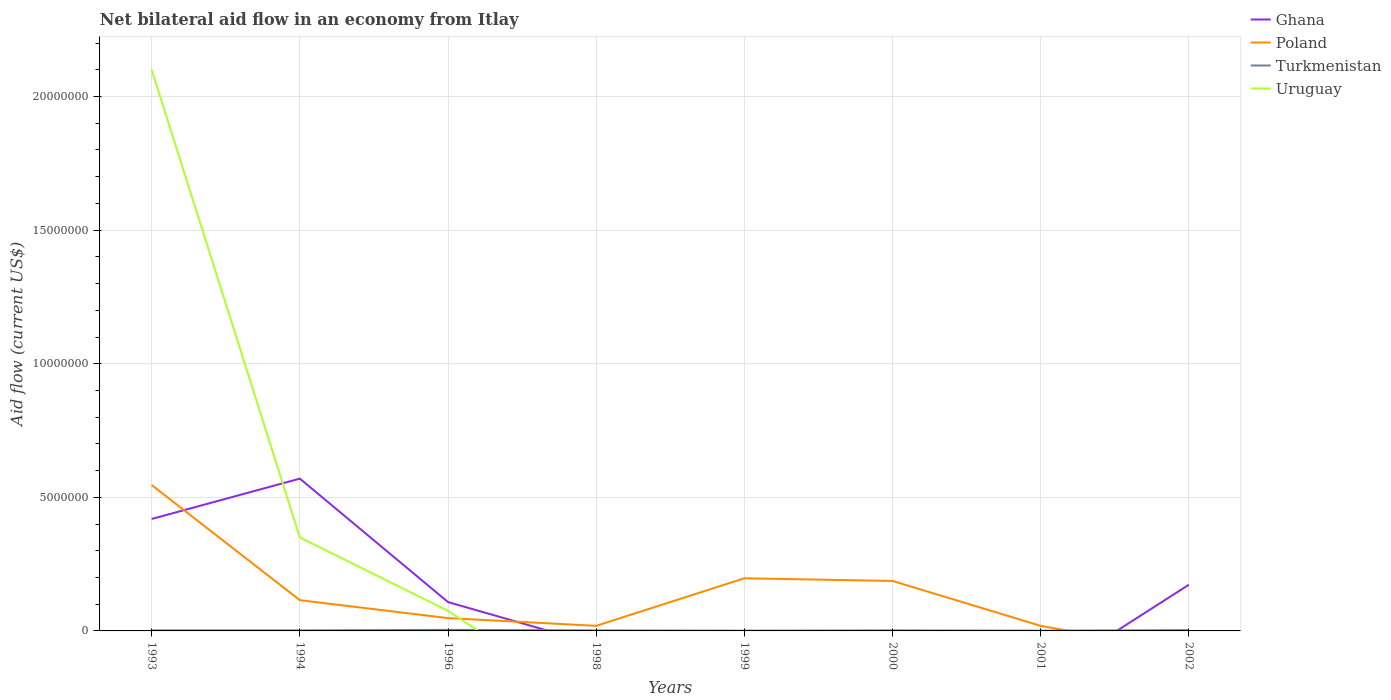Is the number of lines equal to the number of legend labels?
Make the answer very short. No. Is the net bilateral aid flow in Turkmenistan strictly greater than the net bilateral aid flow in Poland over the years?
Your answer should be compact. No. How many lines are there?
Provide a succinct answer. 4. Are the values on the major ticks of Y-axis written in scientific E-notation?
Keep it short and to the point. No. Does the graph contain any zero values?
Your answer should be very brief. Yes. How many legend labels are there?
Your answer should be compact. 4. How are the legend labels stacked?
Ensure brevity in your answer.  Vertical. What is the title of the graph?
Provide a succinct answer. Net bilateral aid flow in an economy from Itlay. What is the Aid flow (current US$) of Ghana in 1993?
Keep it short and to the point. 4.19e+06. What is the Aid flow (current US$) in Poland in 1993?
Provide a succinct answer. 5.46e+06. What is the Aid flow (current US$) in Turkmenistan in 1993?
Your response must be concise. 2.00e+04. What is the Aid flow (current US$) in Uruguay in 1993?
Ensure brevity in your answer.  2.10e+07. What is the Aid flow (current US$) of Ghana in 1994?
Your answer should be very brief. 5.70e+06. What is the Aid flow (current US$) of Poland in 1994?
Your answer should be compact. 1.15e+06. What is the Aid flow (current US$) of Uruguay in 1994?
Offer a very short reply. 3.50e+06. What is the Aid flow (current US$) in Ghana in 1996?
Offer a terse response. 1.08e+06. What is the Aid flow (current US$) of Poland in 1996?
Offer a terse response. 4.80e+05. What is the Aid flow (current US$) of Turkmenistan in 1996?
Your answer should be very brief. 4.00e+04. What is the Aid flow (current US$) in Uruguay in 1996?
Make the answer very short. 7.50e+05. What is the Aid flow (current US$) in Ghana in 1998?
Give a very brief answer. 0. What is the Aid flow (current US$) of Turkmenistan in 1998?
Your answer should be compact. 2.00e+04. What is the Aid flow (current US$) in Uruguay in 1998?
Offer a terse response. 0. What is the Aid flow (current US$) in Poland in 1999?
Your response must be concise. 1.97e+06. What is the Aid flow (current US$) in Ghana in 2000?
Offer a very short reply. 0. What is the Aid flow (current US$) in Poland in 2000?
Ensure brevity in your answer.  1.87e+06. What is the Aid flow (current US$) in Ghana in 2001?
Make the answer very short. 0. What is the Aid flow (current US$) of Turkmenistan in 2001?
Make the answer very short. 10000. What is the Aid flow (current US$) in Uruguay in 2001?
Your answer should be compact. 0. What is the Aid flow (current US$) in Ghana in 2002?
Provide a succinct answer. 1.73e+06. What is the Aid flow (current US$) of Poland in 2002?
Your response must be concise. 0. What is the Aid flow (current US$) of Turkmenistan in 2002?
Provide a short and direct response. 3.00e+04. What is the Aid flow (current US$) in Uruguay in 2002?
Your answer should be compact. 0. Across all years, what is the maximum Aid flow (current US$) of Ghana?
Provide a succinct answer. 5.70e+06. Across all years, what is the maximum Aid flow (current US$) in Poland?
Offer a very short reply. 5.46e+06. Across all years, what is the maximum Aid flow (current US$) in Turkmenistan?
Offer a terse response. 4.00e+04. Across all years, what is the maximum Aid flow (current US$) in Uruguay?
Offer a terse response. 2.10e+07. Across all years, what is the minimum Aid flow (current US$) of Ghana?
Your response must be concise. 0. Across all years, what is the minimum Aid flow (current US$) in Turkmenistan?
Provide a short and direct response. 10000. Across all years, what is the minimum Aid flow (current US$) in Uruguay?
Keep it short and to the point. 0. What is the total Aid flow (current US$) in Ghana in the graph?
Your answer should be very brief. 1.27e+07. What is the total Aid flow (current US$) of Poland in the graph?
Make the answer very short. 1.13e+07. What is the total Aid flow (current US$) of Uruguay in the graph?
Offer a very short reply. 2.52e+07. What is the difference between the Aid flow (current US$) in Ghana in 1993 and that in 1994?
Offer a very short reply. -1.51e+06. What is the difference between the Aid flow (current US$) in Poland in 1993 and that in 1994?
Your answer should be compact. 4.31e+06. What is the difference between the Aid flow (current US$) in Turkmenistan in 1993 and that in 1994?
Give a very brief answer. 0. What is the difference between the Aid flow (current US$) of Uruguay in 1993 and that in 1994?
Give a very brief answer. 1.75e+07. What is the difference between the Aid flow (current US$) in Ghana in 1993 and that in 1996?
Provide a short and direct response. 3.11e+06. What is the difference between the Aid flow (current US$) in Poland in 1993 and that in 1996?
Make the answer very short. 4.98e+06. What is the difference between the Aid flow (current US$) in Turkmenistan in 1993 and that in 1996?
Keep it short and to the point. -2.00e+04. What is the difference between the Aid flow (current US$) of Uruguay in 1993 and that in 1996?
Make the answer very short. 2.02e+07. What is the difference between the Aid flow (current US$) of Poland in 1993 and that in 1998?
Ensure brevity in your answer.  5.27e+06. What is the difference between the Aid flow (current US$) of Turkmenistan in 1993 and that in 1998?
Provide a short and direct response. 0. What is the difference between the Aid flow (current US$) in Poland in 1993 and that in 1999?
Ensure brevity in your answer.  3.49e+06. What is the difference between the Aid flow (current US$) of Poland in 1993 and that in 2000?
Your response must be concise. 3.59e+06. What is the difference between the Aid flow (current US$) in Turkmenistan in 1993 and that in 2000?
Your answer should be compact. 0. What is the difference between the Aid flow (current US$) in Poland in 1993 and that in 2001?
Your answer should be very brief. 5.27e+06. What is the difference between the Aid flow (current US$) of Turkmenistan in 1993 and that in 2001?
Provide a short and direct response. 10000. What is the difference between the Aid flow (current US$) of Ghana in 1993 and that in 2002?
Provide a succinct answer. 2.46e+06. What is the difference between the Aid flow (current US$) of Turkmenistan in 1993 and that in 2002?
Your answer should be very brief. -10000. What is the difference between the Aid flow (current US$) in Ghana in 1994 and that in 1996?
Give a very brief answer. 4.62e+06. What is the difference between the Aid flow (current US$) of Poland in 1994 and that in 1996?
Offer a terse response. 6.70e+05. What is the difference between the Aid flow (current US$) in Turkmenistan in 1994 and that in 1996?
Keep it short and to the point. -2.00e+04. What is the difference between the Aid flow (current US$) in Uruguay in 1994 and that in 1996?
Your answer should be compact. 2.75e+06. What is the difference between the Aid flow (current US$) of Poland in 1994 and that in 1998?
Offer a terse response. 9.60e+05. What is the difference between the Aid flow (current US$) of Turkmenistan in 1994 and that in 1998?
Keep it short and to the point. 0. What is the difference between the Aid flow (current US$) in Poland in 1994 and that in 1999?
Your answer should be compact. -8.20e+05. What is the difference between the Aid flow (current US$) of Turkmenistan in 1994 and that in 1999?
Offer a terse response. 10000. What is the difference between the Aid flow (current US$) in Poland in 1994 and that in 2000?
Give a very brief answer. -7.20e+05. What is the difference between the Aid flow (current US$) in Poland in 1994 and that in 2001?
Offer a very short reply. 9.60e+05. What is the difference between the Aid flow (current US$) of Turkmenistan in 1994 and that in 2001?
Your answer should be very brief. 10000. What is the difference between the Aid flow (current US$) in Ghana in 1994 and that in 2002?
Provide a short and direct response. 3.97e+06. What is the difference between the Aid flow (current US$) in Turkmenistan in 1994 and that in 2002?
Offer a terse response. -10000. What is the difference between the Aid flow (current US$) in Poland in 1996 and that in 1999?
Make the answer very short. -1.49e+06. What is the difference between the Aid flow (current US$) of Poland in 1996 and that in 2000?
Your answer should be compact. -1.39e+06. What is the difference between the Aid flow (current US$) in Turkmenistan in 1996 and that in 2000?
Your answer should be compact. 2.00e+04. What is the difference between the Aid flow (current US$) of Poland in 1996 and that in 2001?
Your answer should be very brief. 2.90e+05. What is the difference between the Aid flow (current US$) in Turkmenistan in 1996 and that in 2001?
Offer a very short reply. 3.00e+04. What is the difference between the Aid flow (current US$) in Ghana in 1996 and that in 2002?
Make the answer very short. -6.50e+05. What is the difference between the Aid flow (current US$) of Turkmenistan in 1996 and that in 2002?
Make the answer very short. 10000. What is the difference between the Aid flow (current US$) of Poland in 1998 and that in 1999?
Provide a short and direct response. -1.78e+06. What is the difference between the Aid flow (current US$) of Poland in 1998 and that in 2000?
Offer a terse response. -1.68e+06. What is the difference between the Aid flow (current US$) of Turkmenistan in 1998 and that in 2000?
Your answer should be compact. 0. What is the difference between the Aid flow (current US$) of Poland in 1998 and that in 2001?
Provide a succinct answer. 0. What is the difference between the Aid flow (current US$) of Turkmenistan in 1998 and that in 2001?
Offer a terse response. 10000. What is the difference between the Aid flow (current US$) of Poland in 1999 and that in 2000?
Your answer should be compact. 1.00e+05. What is the difference between the Aid flow (current US$) of Poland in 1999 and that in 2001?
Your answer should be very brief. 1.78e+06. What is the difference between the Aid flow (current US$) in Turkmenistan in 1999 and that in 2001?
Provide a short and direct response. 0. What is the difference between the Aid flow (current US$) of Poland in 2000 and that in 2001?
Offer a very short reply. 1.68e+06. What is the difference between the Aid flow (current US$) of Ghana in 1993 and the Aid flow (current US$) of Poland in 1994?
Provide a succinct answer. 3.04e+06. What is the difference between the Aid flow (current US$) of Ghana in 1993 and the Aid flow (current US$) of Turkmenistan in 1994?
Keep it short and to the point. 4.17e+06. What is the difference between the Aid flow (current US$) in Ghana in 1993 and the Aid flow (current US$) in Uruguay in 1994?
Your answer should be very brief. 6.90e+05. What is the difference between the Aid flow (current US$) of Poland in 1993 and the Aid flow (current US$) of Turkmenistan in 1994?
Provide a short and direct response. 5.44e+06. What is the difference between the Aid flow (current US$) in Poland in 1993 and the Aid flow (current US$) in Uruguay in 1994?
Your answer should be compact. 1.96e+06. What is the difference between the Aid flow (current US$) in Turkmenistan in 1993 and the Aid flow (current US$) in Uruguay in 1994?
Give a very brief answer. -3.48e+06. What is the difference between the Aid flow (current US$) of Ghana in 1993 and the Aid flow (current US$) of Poland in 1996?
Provide a succinct answer. 3.71e+06. What is the difference between the Aid flow (current US$) in Ghana in 1993 and the Aid flow (current US$) in Turkmenistan in 1996?
Offer a very short reply. 4.15e+06. What is the difference between the Aid flow (current US$) of Ghana in 1993 and the Aid flow (current US$) of Uruguay in 1996?
Keep it short and to the point. 3.44e+06. What is the difference between the Aid flow (current US$) of Poland in 1993 and the Aid flow (current US$) of Turkmenistan in 1996?
Keep it short and to the point. 5.42e+06. What is the difference between the Aid flow (current US$) of Poland in 1993 and the Aid flow (current US$) of Uruguay in 1996?
Your response must be concise. 4.71e+06. What is the difference between the Aid flow (current US$) of Turkmenistan in 1993 and the Aid flow (current US$) of Uruguay in 1996?
Ensure brevity in your answer.  -7.30e+05. What is the difference between the Aid flow (current US$) of Ghana in 1993 and the Aid flow (current US$) of Turkmenistan in 1998?
Your response must be concise. 4.17e+06. What is the difference between the Aid flow (current US$) of Poland in 1993 and the Aid flow (current US$) of Turkmenistan in 1998?
Provide a succinct answer. 5.44e+06. What is the difference between the Aid flow (current US$) of Ghana in 1993 and the Aid flow (current US$) of Poland in 1999?
Offer a very short reply. 2.22e+06. What is the difference between the Aid flow (current US$) in Ghana in 1993 and the Aid flow (current US$) in Turkmenistan in 1999?
Give a very brief answer. 4.18e+06. What is the difference between the Aid flow (current US$) in Poland in 1993 and the Aid flow (current US$) in Turkmenistan in 1999?
Offer a very short reply. 5.45e+06. What is the difference between the Aid flow (current US$) in Ghana in 1993 and the Aid flow (current US$) in Poland in 2000?
Keep it short and to the point. 2.32e+06. What is the difference between the Aid flow (current US$) of Ghana in 1993 and the Aid flow (current US$) of Turkmenistan in 2000?
Provide a short and direct response. 4.17e+06. What is the difference between the Aid flow (current US$) of Poland in 1993 and the Aid flow (current US$) of Turkmenistan in 2000?
Your answer should be very brief. 5.44e+06. What is the difference between the Aid flow (current US$) in Ghana in 1993 and the Aid flow (current US$) in Turkmenistan in 2001?
Provide a short and direct response. 4.18e+06. What is the difference between the Aid flow (current US$) in Poland in 1993 and the Aid flow (current US$) in Turkmenistan in 2001?
Provide a short and direct response. 5.45e+06. What is the difference between the Aid flow (current US$) of Ghana in 1993 and the Aid flow (current US$) of Turkmenistan in 2002?
Make the answer very short. 4.16e+06. What is the difference between the Aid flow (current US$) of Poland in 1993 and the Aid flow (current US$) of Turkmenistan in 2002?
Provide a short and direct response. 5.43e+06. What is the difference between the Aid flow (current US$) of Ghana in 1994 and the Aid flow (current US$) of Poland in 1996?
Ensure brevity in your answer.  5.22e+06. What is the difference between the Aid flow (current US$) of Ghana in 1994 and the Aid flow (current US$) of Turkmenistan in 1996?
Offer a terse response. 5.66e+06. What is the difference between the Aid flow (current US$) in Ghana in 1994 and the Aid flow (current US$) in Uruguay in 1996?
Make the answer very short. 4.95e+06. What is the difference between the Aid flow (current US$) in Poland in 1994 and the Aid flow (current US$) in Turkmenistan in 1996?
Provide a short and direct response. 1.11e+06. What is the difference between the Aid flow (current US$) of Poland in 1994 and the Aid flow (current US$) of Uruguay in 1996?
Your response must be concise. 4.00e+05. What is the difference between the Aid flow (current US$) of Turkmenistan in 1994 and the Aid flow (current US$) of Uruguay in 1996?
Offer a very short reply. -7.30e+05. What is the difference between the Aid flow (current US$) in Ghana in 1994 and the Aid flow (current US$) in Poland in 1998?
Your answer should be compact. 5.51e+06. What is the difference between the Aid flow (current US$) in Ghana in 1994 and the Aid flow (current US$) in Turkmenistan in 1998?
Provide a succinct answer. 5.68e+06. What is the difference between the Aid flow (current US$) in Poland in 1994 and the Aid flow (current US$) in Turkmenistan in 1998?
Ensure brevity in your answer.  1.13e+06. What is the difference between the Aid flow (current US$) in Ghana in 1994 and the Aid flow (current US$) in Poland in 1999?
Ensure brevity in your answer.  3.73e+06. What is the difference between the Aid flow (current US$) of Ghana in 1994 and the Aid flow (current US$) of Turkmenistan in 1999?
Make the answer very short. 5.69e+06. What is the difference between the Aid flow (current US$) in Poland in 1994 and the Aid flow (current US$) in Turkmenistan in 1999?
Make the answer very short. 1.14e+06. What is the difference between the Aid flow (current US$) of Ghana in 1994 and the Aid flow (current US$) of Poland in 2000?
Your response must be concise. 3.83e+06. What is the difference between the Aid flow (current US$) in Ghana in 1994 and the Aid flow (current US$) in Turkmenistan in 2000?
Give a very brief answer. 5.68e+06. What is the difference between the Aid flow (current US$) of Poland in 1994 and the Aid flow (current US$) of Turkmenistan in 2000?
Offer a very short reply. 1.13e+06. What is the difference between the Aid flow (current US$) of Ghana in 1994 and the Aid flow (current US$) of Poland in 2001?
Your response must be concise. 5.51e+06. What is the difference between the Aid flow (current US$) in Ghana in 1994 and the Aid flow (current US$) in Turkmenistan in 2001?
Provide a succinct answer. 5.69e+06. What is the difference between the Aid flow (current US$) of Poland in 1994 and the Aid flow (current US$) of Turkmenistan in 2001?
Provide a succinct answer. 1.14e+06. What is the difference between the Aid flow (current US$) in Ghana in 1994 and the Aid flow (current US$) in Turkmenistan in 2002?
Ensure brevity in your answer.  5.67e+06. What is the difference between the Aid flow (current US$) in Poland in 1994 and the Aid flow (current US$) in Turkmenistan in 2002?
Offer a very short reply. 1.12e+06. What is the difference between the Aid flow (current US$) of Ghana in 1996 and the Aid flow (current US$) of Poland in 1998?
Give a very brief answer. 8.90e+05. What is the difference between the Aid flow (current US$) of Ghana in 1996 and the Aid flow (current US$) of Turkmenistan in 1998?
Offer a very short reply. 1.06e+06. What is the difference between the Aid flow (current US$) in Poland in 1996 and the Aid flow (current US$) in Turkmenistan in 1998?
Provide a short and direct response. 4.60e+05. What is the difference between the Aid flow (current US$) in Ghana in 1996 and the Aid flow (current US$) in Poland in 1999?
Provide a succinct answer. -8.90e+05. What is the difference between the Aid flow (current US$) in Ghana in 1996 and the Aid flow (current US$) in Turkmenistan in 1999?
Your answer should be very brief. 1.07e+06. What is the difference between the Aid flow (current US$) of Poland in 1996 and the Aid flow (current US$) of Turkmenistan in 1999?
Give a very brief answer. 4.70e+05. What is the difference between the Aid flow (current US$) in Ghana in 1996 and the Aid flow (current US$) in Poland in 2000?
Ensure brevity in your answer.  -7.90e+05. What is the difference between the Aid flow (current US$) in Ghana in 1996 and the Aid flow (current US$) in Turkmenistan in 2000?
Keep it short and to the point. 1.06e+06. What is the difference between the Aid flow (current US$) in Ghana in 1996 and the Aid flow (current US$) in Poland in 2001?
Your answer should be compact. 8.90e+05. What is the difference between the Aid flow (current US$) in Ghana in 1996 and the Aid flow (current US$) in Turkmenistan in 2001?
Offer a very short reply. 1.07e+06. What is the difference between the Aid flow (current US$) in Poland in 1996 and the Aid flow (current US$) in Turkmenistan in 2001?
Your answer should be compact. 4.70e+05. What is the difference between the Aid flow (current US$) in Ghana in 1996 and the Aid flow (current US$) in Turkmenistan in 2002?
Your response must be concise. 1.05e+06. What is the difference between the Aid flow (current US$) of Poland in 1996 and the Aid flow (current US$) of Turkmenistan in 2002?
Your answer should be compact. 4.50e+05. What is the difference between the Aid flow (current US$) of Poland in 1998 and the Aid flow (current US$) of Turkmenistan in 2001?
Offer a very short reply. 1.80e+05. What is the difference between the Aid flow (current US$) in Poland in 1999 and the Aid flow (current US$) in Turkmenistan in 2000?
Provide a succinct answer. 1.95e+06. What is the difference between the Aid flow (current US$) in Poland in 1999 and the Aid flow (current US$) in Turkmenistan in 2001?
Offer a very short reply. 1.96e+06. What is the difference between the Aid flow (current US$) in Poland in 1999 and the Aid flow (current US$) in Turkmenistan in 2002?
Your response must be concise. 1.94e+06. What is the difference between the Aid flow (current US$) in Poland in 2000 and the Aid flow (current US$) in Turkmenistan in 2001?
Offer a terse response. 1.86e+06. What is the difference between the Aid flow (current US$) of Poland in 2000 and the Aid flow (current US$) of Turkmenistan in 2002?
Your answer should be compact. 1.84e+06. What is the difference between the Aid flow (current US$) in Poland in 2001 and the Aid flow (current US$) in Turkmenistan in 2002?
Keep it short and to the point. 1.60e+05. What is the average Aid flow (current US$) of Ghana per year?
Offer a very short reply. 1.59e+06. What is the average Aid flow (current US$) of Poland per year?
Offer a very short reply. 1.41e+06. What is the average Aid flow (current US$) in Turkmenistan per year?
Make the answer very short. 2.12e+04. What is the average Aid flow (current US$) in Uruguay per year?
Provide a short and direct response. 3.16e+06. In the year 1993, what is the difference between the Aid flow (current US$) of Ghana and Aid flow (current US$) of Poland?
Your response must be concise. -1.27e+06. In the year 1993, what is the difference between the Aid flow (current US$) of Ghana and Aid flow (current US$) of Turkmenistan?
Give a very brief answer. 4.17e+06. In the year 1993, what is the difference between the Aid flow (current US$) in Ghana and Aid flow (current US$) in Uruguay?
Give a very brief answer. -1.68e+07. In the year 1993, what is the difference between the Aid flow (current US$) of Poland and Aid flow (current US$) of Turkmenistan?
Your answer should be very brief. 5.44e+06. In the year 1993, what is the difference between the Aid flow (current US$) in Poland and Aid flow (current US$) in Uruguay?
Provide a succinct answer. -1.55e+07. In the year 1993, what is the difference between the Aid flow (current US$) of Turkmenistan and Aid flow (current US$) of Uruguay?
Your answer should be compact. -2.10e+07. In the year 1994, what is the difference between the Aid flow (current US$) in Ghana and Aid flow (current US$) in Poland?
Keep it short and to the point. 4.55e+06. In the year 1994, what is the difference between the Aid flow (current US$) of Ghana and Aid flow (current US$) of Turkmenistan?
Your response must be concise. 5.68e+06. In the year 1994, what is the difference between the Aid flow (current US$) of Ghana and Aid flow (current US$) of Uruguay?
Your response must be concise. 2.20e+06. In the year 1994, what is the difference between the Aid flow (current US$) of Poland and Aid flow (current US$) of Turkmenistan?
Give a very brief answer. 1.13e+06. In the year 1994, what is the difference between the Aid flow (current US$) of Poland and Aid flow (current US$) of Uruguay?
Provide a short and direct response. -2.35e+06. In the year 1994, what is the difference between the Aid flow (current US$) in Turkmenistan and Aid flow (current US$) in Uruguay?
Give a very brief answer. -3.48e+06. In the year 1996, what is the difference between the Aid flow (current US$) of Ghana and Aid flow (current US$) of Poland?
Keep it short and to the point. 6.00e+05. In the year 1996, what is the difference between the Aid flow (current US$) in Ghana and Aid flow (current US$) in Turkmenistan?
Provide a short and direct response. 1.04e+06. In the year 1996, what is the difference between the Aid flow (current US$) in Ghana and Aid flow (current US$) in Uruguay?
Offer a terse response. 3.30e+05. In the year 1996, what is the difference between the Aid flow (current US$) of Poland and Aid flow (current US$) of Turkmenistan?
Offer a very short reply. 4.40e+05. In the year 1996, what is the difference between the Aid flow (current US$) of Turkmenistan and Aid flow (current US$) of Uruguay?
Your response must be concise. -7.10e+05. In the year 1998, what is the difference between the Aid flow (current US$) in Poland and Aid flow (current US$) in Turkmenistan?
Keep it short and to the point. 1.70e+05. In the year 1999, what is the difference between the Aid flow (current US$) of Poland and Aid flow (current US$) of Turkmenistan?
Make the answer very short. 1.96e+06. In the year 2000, what is the difference between the Aid flow (current US$) of Poland and Aid flow (current US$) of Turkmenistan?
Provide a succinct answer. 1.85e+06. In the year 2002, what is the difference between the Aid flow (current US$) in Ghana and Aid flow (current US$) in Turkmenistan?
Your answer should be very brief. 1.70e+06. What is the ratio of the Aid flow (current US$) of Ghana in 1993 to that in 1994?
Give a very brief answer. 0.74. What is the ratio of the Aid flow (current US$) in Poland in 1993 to that in 1994?
Ensure brevity in your answer.  4.75. What is the ratio of the Aid flow (current US$) in Turkmenistan in 1993 to that in 1994?
Keep it short and to the point. 1. What is the ratio of the Aid flow (current US$) of Ghana in 1993 to that in 1996?
Provide a succinct answer. 3.88. What is the ratio of the Aid flow (current US$) in Poland in 1993 to that in 1996?
Keep it short and to the point. 11.38. What is the ratio of the Aid flow (current US$) of Poland in 1993 to that in 1998?
Your answer should be very brief. 28.74. What is the ratio of the Aid flow (current US$) of Turkmenistan in 1993 to that in 1998?
Your answer should be compact. 1. What is the ratio of the Aid flow (current US$) of Poland in 1993 to that in 1999?
Ensure brevity in your answer.  2.77. What is the ratio of the Aid flow (current US$) of Poland in 1993 to that in 2000?
Offer a terse response. 2.92. What is the ratio of the Aid flow (current US$) of Turkmenistan in 1993 to that in 2000?
Give a very brief answer. 1. What is the ratio of the Aid flow (current US$) of Poland in 1993 to that in 2001?
Make the answer very short. 28.74. What is the ratio of the Aid flow (current US$) in Ghana in 1993 to that in 2002?
Provide a short and direct response. 2.42. What is the ratio of the Aid flow (current US$) of Turkmenistan in 1993 to that in 2002?
Keep it short and to the point. 0.67. What is the ratio of the Aid flow (current US$) of Ghana in 1994 to that in 1996?
Keep it short and to the point. 5.28. What is the ratio of the Aid flow (current US$) of Poland in 1994 to that in 1996?
Offer a terse response. 2.4. What is the ratio of the Aid flow (current US$) in Uruguay in 1994 to that in 1996?
Provide a succinct answer. 4.67. What is the ratio of the Aid flow (current US$) of Poland in 1994 to that in 1998?
Make the answer very short. 6.05. What is the ratio of the Aid flow (current US$) in Turkmenistan in 1994 to that in 1998?
Offer a terse response. 1. What is the ratio of the Aid flow (current US$) in Poland in 1994 to that in 1999?
Give a very brief answer. 0.58. What is the ratio of the Aid flow (current US$) in Turkmenistan in 1994 to that in 1999?
Keep it short and to the point. 2. What is the ratio of the Aid flow (current US$) in Poland in 1994 to that in 2000?
Offer a very short reply. 0.61. What is the ratio of the Aid flow (current US$) of Turkmenistan in 1994 to that in 2000?
Make the answer very short. 1. What is the ratio of the Aid flow (current US$) in Poland in 1994 to that in 2001?
Your answer should be compact. 6.05. What is the ratio of the Aid flow (current US$) in Ghana in 1994 to that in 2002?
Your answer should be very brief. 3.29. What is the ratio of the Aid flow (current US$) in Poland in 1996 to that in 1998?
Offer a terse response. 2.53. What is the ratio of the Aid flow (current US$) of Turkmenistan in 1996 to that in 1998?
Keep it short and to the point. 2. What is the ratio of the Aid flow (current US$) of Poland in 1996 to that in 1999?
Offer a very short reply. 0.24. What is the ratio of the Aid flow (current US$) in Poland in 1996 to that in 2000?
Keep it short and to the point. 0.26. What is the ratio of the Aid flow (current US$) of Poland in 1996 to that in 2001?
Keep it short and to the point. 2.53. What is the ratio of the Aid flow (current US$) of Ghana in 1996 to that in 2002?
Provide a short and direct response. 0.62. What is the ratio of the Aid flow (current US$) in Poland in 1998 to that in 1999?
Your answer should be very brief. 0.1. What is the ratio of the Aid flow (current US$) of Turkmenistan in 1998 to that in 1999?
Ensure brevity in your answer.  2. What is the ratio of the Aid flow (current US$) in Poland in 1998 to that in 2000?
Make the answer very short. 0.1. What is the ratio of the Aid flow (current US$) in Turkmenistan in 1998 to that in 2001?
Keep it short and to the point. 2. What is the ratio of the Aid flow (current US$) in Turkmenistan in 1998 to that in 2002?
Provide a short and direct response. 0.67. What is the ratio of the Aid flow (current US$) of Poland in 1999 to that in 2000?
Keep it short and to the point. 1.05. What is the ratio of the Aid flow (current US$) of Turkmenistan in 1999 to that in 2000?
Offer a terse response. 0.5. What is the ratio of the Aid flow (current US$) of Poland in 1999 to that in 2001?
Your answer should be very brief. 10.37. What is the ratio of the Aid flow (current US$) of Turkmenistan in 1999 to that in 2002?
Provide a short and direct response. 0.33. What is the ratio of the Aid flow (current US$) of Poland in 2000 to that in 2001?
Make the answer very short. 9.84. What is the difference between the highest and the second highest Aid flow (current US$) in Ghana?
Ensure brevity in your answer.  1.51e+06. What is the difference between the highest and the second highest Aid flow (current US$) in Poland?
Provide a short and direct response. 3.49e+06. What is the difference between the highest and the second highest Aid flow (current US$) in Turkmenistan?
Your answer should be very brief. 10000. What is the difference between the highest and the second highest Aid flow (current US$) of Uruguay?
Provide a succinct answer. 1.75e+07. What is the difference between the highest and the lowest Aid flow (current US$) of Ghana?
Offer a terse response. 5.70e+06. What is the difference between the highest and the lowest Aid flow (current US$) of Poland?
Provide a short and direct response. 5.46e+06. What is the difference between the highest and the lowest Aid flow (current US$) of Turkmenistan?
Ensure brevity in your answer.  3.00e+04. What is the difference between the highest and the lowest Aid flow (current US$) of Uruguay?
Your answer should be compact. 2.10e+07. 